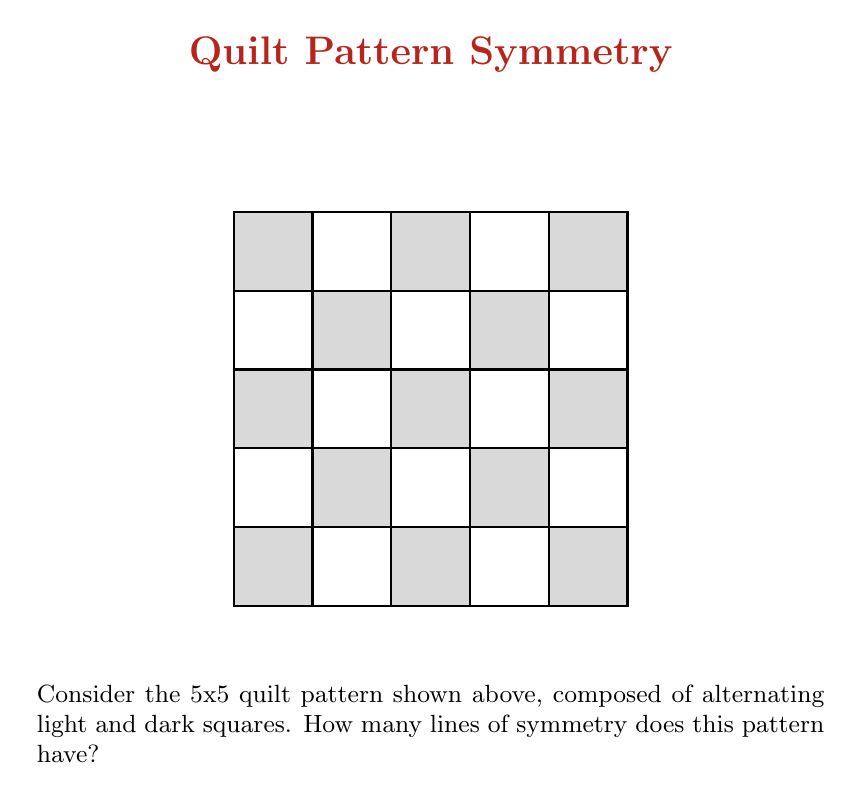Show me your answer to this math problem. To determine the number of lines of symmetry in this quilt pattern, we need to consider all possible ways the pattern remains unchanged when reflected across a line. Let's analyze step-by-step:

1. Diagonal symmetry:
   a) There is a line of symmetry from the top-left corner to the bottom-right corner.
   b) There is also a line of symmetry from the top-right corner to the bottom-left corner.

2. Vertical symmetry:
   The pattern is symmetric about the vertical line passing through the center of the quilt.

3. Horizontal symmetry:
   The pattern is symmetric about the horizontal line passing through the center of the quilt.

To verify these symmetries, we can imagine folding the quilt along each of these lines:
- Folding along either diagonal would make the pattern match perfectly.
- Folding vertically down the middle would make the left and right halves match.
- Folding horizontally across the middle would make the top and bottom halves match.

There are no other lines of symmetry because:
- Any other diagonal line would not maintain the alternating pattern of light and dark squares.
- Any other vertical or horizontal line would not divide the quilt into equal halves that match.

Therefore, we have identified a total of 4 lines of symmetry in this quilt pattern.
Answer: 4 